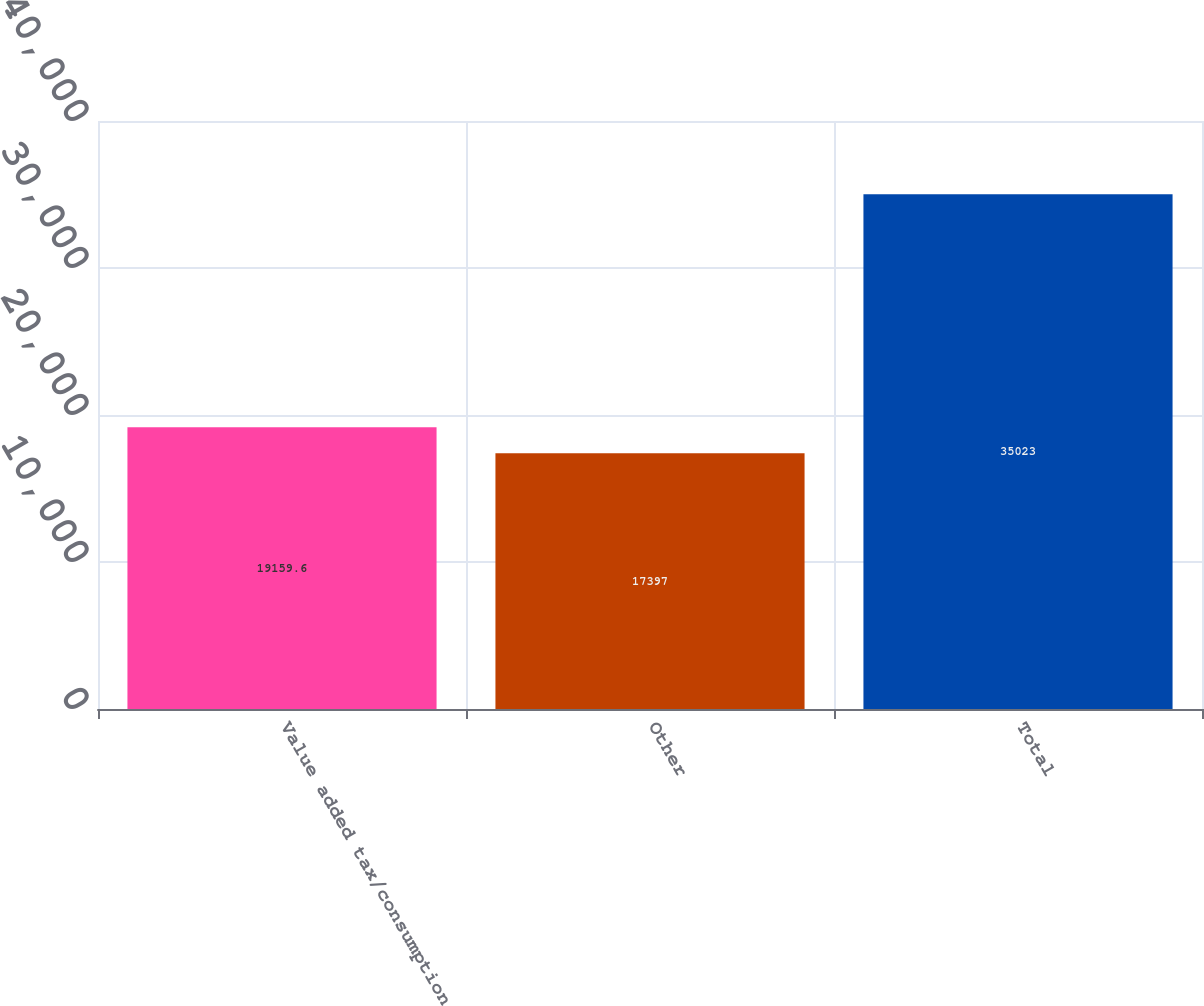Convert chart to OTSL. <chart><loc_0><loc_0><loc_500><loc_500><bar_chart><fcel>Value added tax/consumption<fcel>Other<fcel>Total<nl><fcel>19159.6<fcel>17397<fcel>35023<nl></chart> 